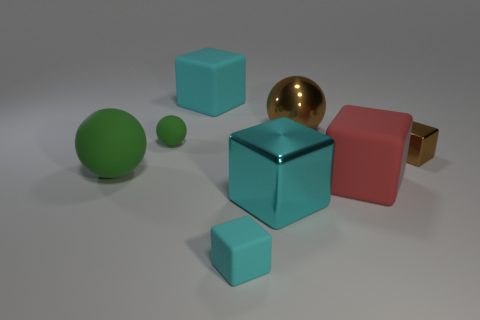Are there any tiny green things that have the same shape as the cyan shiny thing?
Ensure brevity in your answer.  No. Do the large metallic ball and the large matte ball have the same color?
Give a very brief answer. No. There is a block on the left side of the small cube that is in front of the brown block; what is its material?
Provide a short and direct response. Rubber. What size is the red object?
Offer a terse response. Large. What is the size of the green thing that is made of the same material as the tiny ball?
Provide a short and direct response. Large. Does the cyan matte thing that is behind the brown metallic ball have the same size as the red rubber object?
Offer a terse response. Yes. The rubber object that is right of the large cyan thing to the right of the cyan matte cube behind the tiny green ball is what shape?
Provide a short and direct response. Cube. What number of things are small red rubber cubes or big cubes that are to the right of the large brown metal ball?
Ensure brevity in your answer.  1. There is a brown metallic thing that is to the right of the red rubber object; what size is it?
Make the answer very short. Small. The large matte thing that is the same color as the tiny matte cube is what shape?
Ensure brevity in your answer.  Cube. 